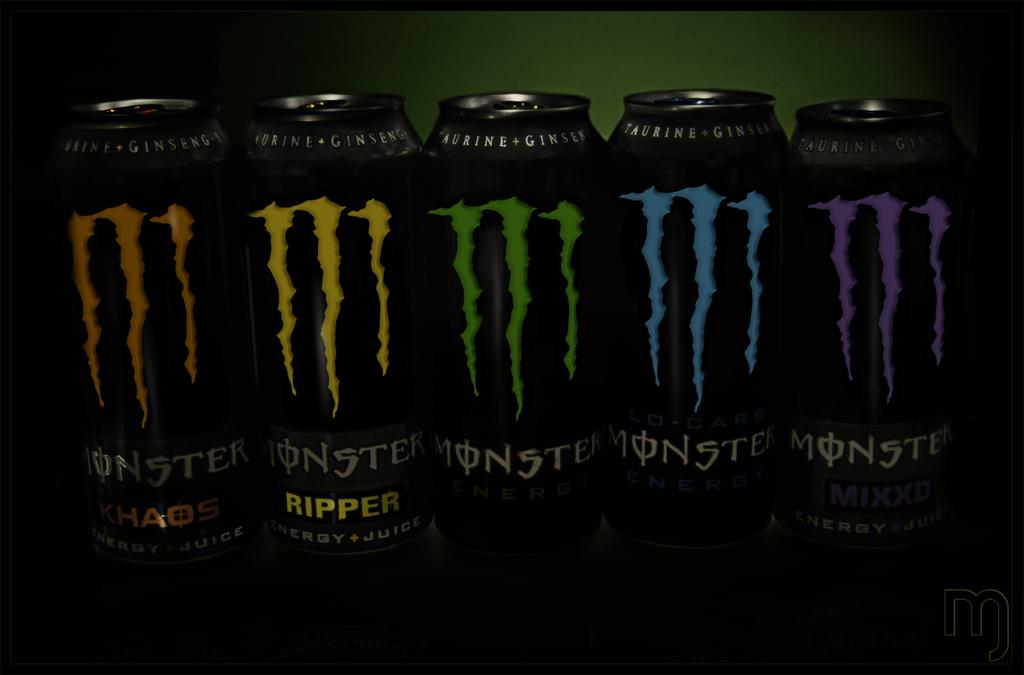Provide a one-sentence caption for the provided image. In a row are five different cans of Monster Engergy, including Choas, Ripper, and Mixxd. 